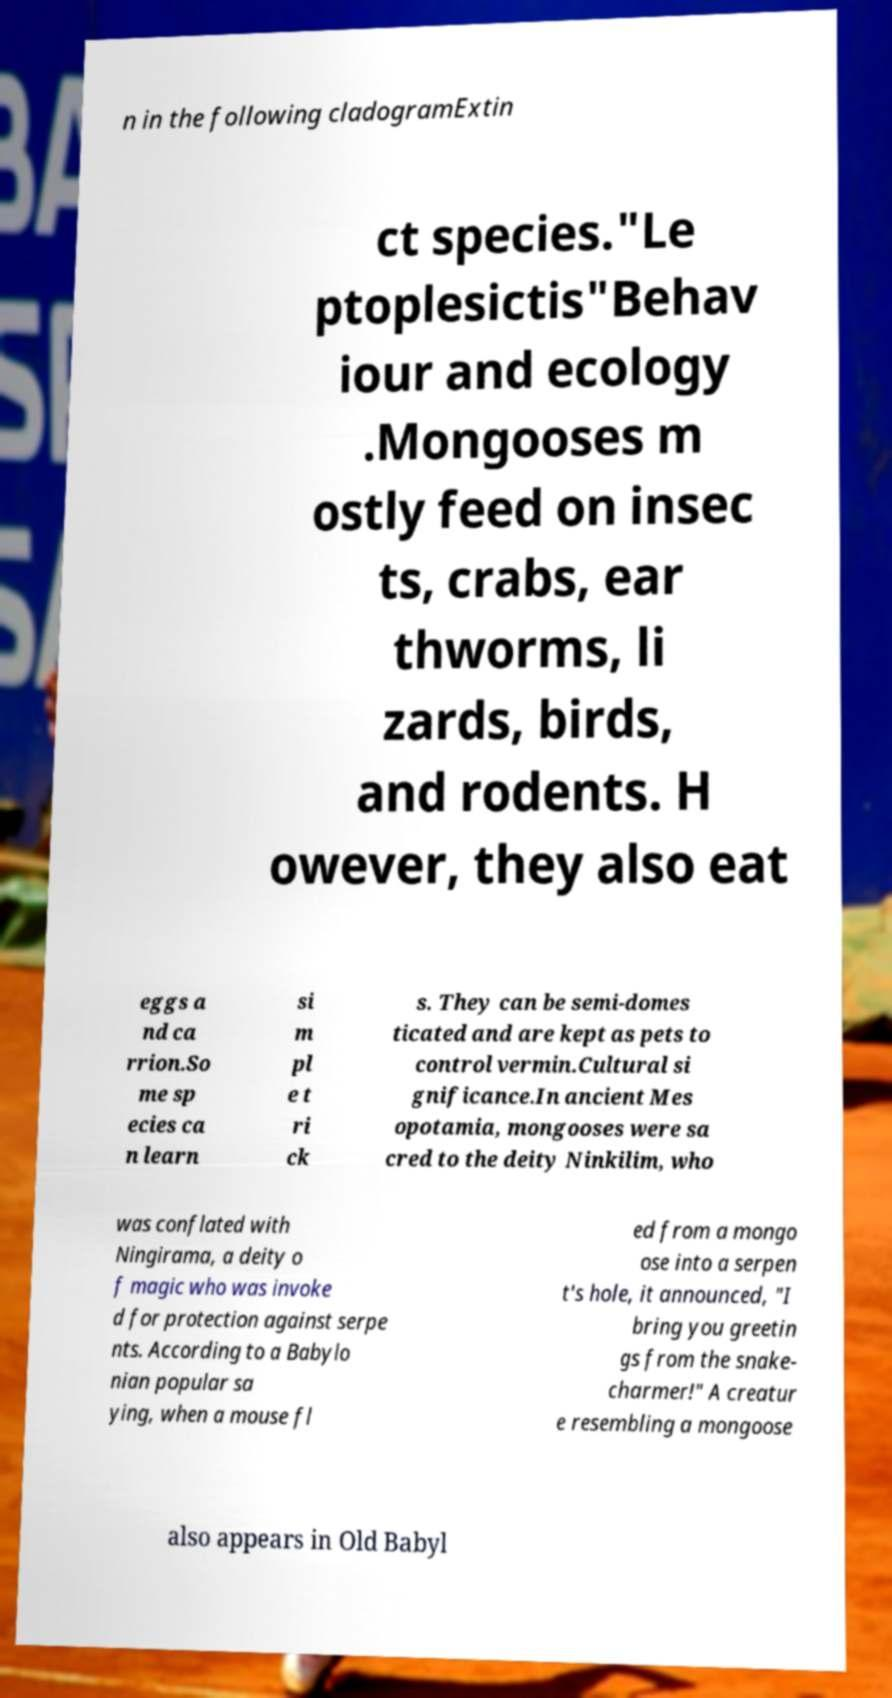Please identify and transcribe the text found in this image. n in the following cladogramExtin ct species."Le ptoplesictis"Behav iour and ecology .Mongooses m ostly feed on insec ts, crabs, ear thworms, li zards, birds, and rodents. H owever, they also eat eggs a nd ca rrion.So me sp ecies ca n learn si m pl e t ri ck s. They can be semi-domes ticated and are kept as pets to control vermin.Cultural si gnificance.In ancient Mes opotamia, mongooses were sa cred to the deity Ninkilim, who was conflated with Ningirama, a deity o f magic who was invoke d for protection against serpe nts. According to a Babylo nian popular sa ying, when a mouse fl ed from a mongo ose into a serpen t's hole, it announced, "I bring you greetin gs from the snake- charmer!" A creatur e resembling a mongoose also appears in Old Babyl 